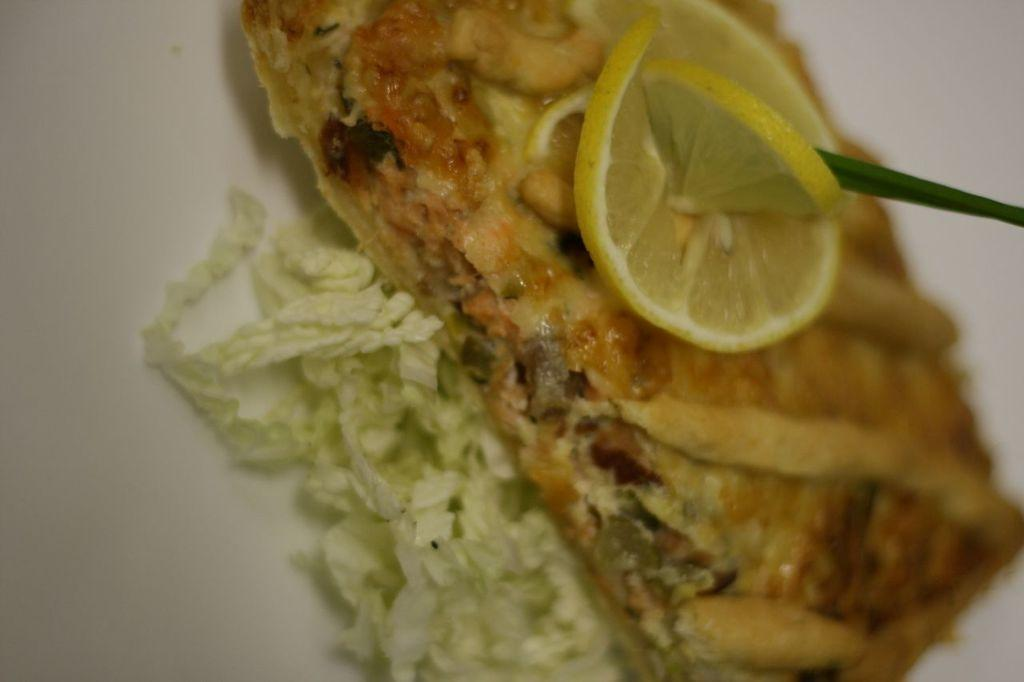What is the main subject of the image? The main subject of the image is a food item. How is the food item decorated? The food item is decorated with lemon slices. How many cacti are providing shade for the food item in the image? There are no cacti present in the image, and therefore no shade is provided for the food item. What time is indicated by the clock in the image? There is no clock present in the image. 